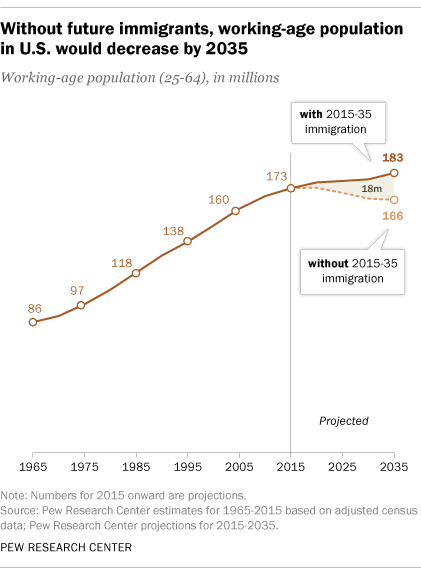Specify some key components in this picture. In 1965, the value was 86. The difference in the value of the working age population with and without immigration in the year 2035 is 17%. 